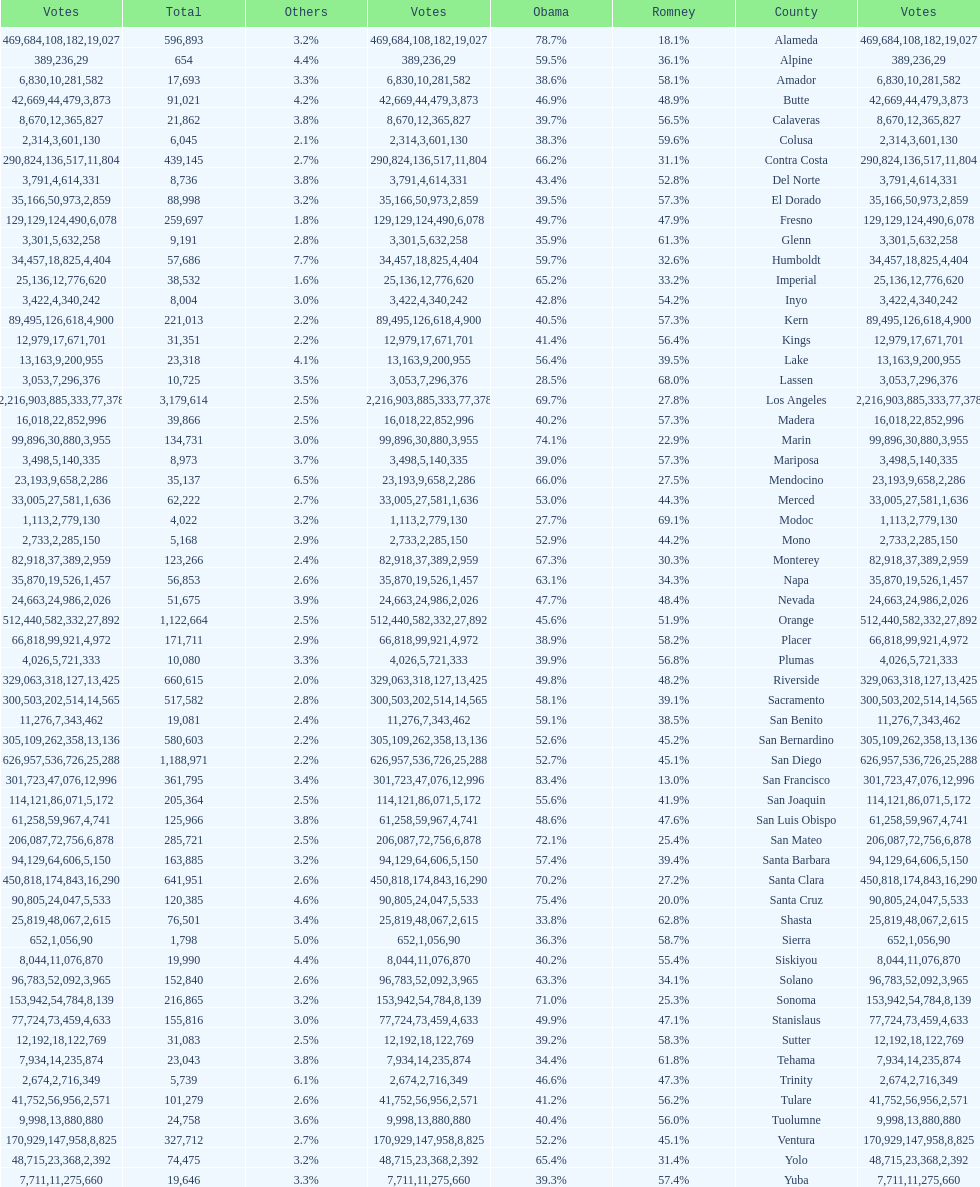What county is just before del norte on the list? Contra Costa. 